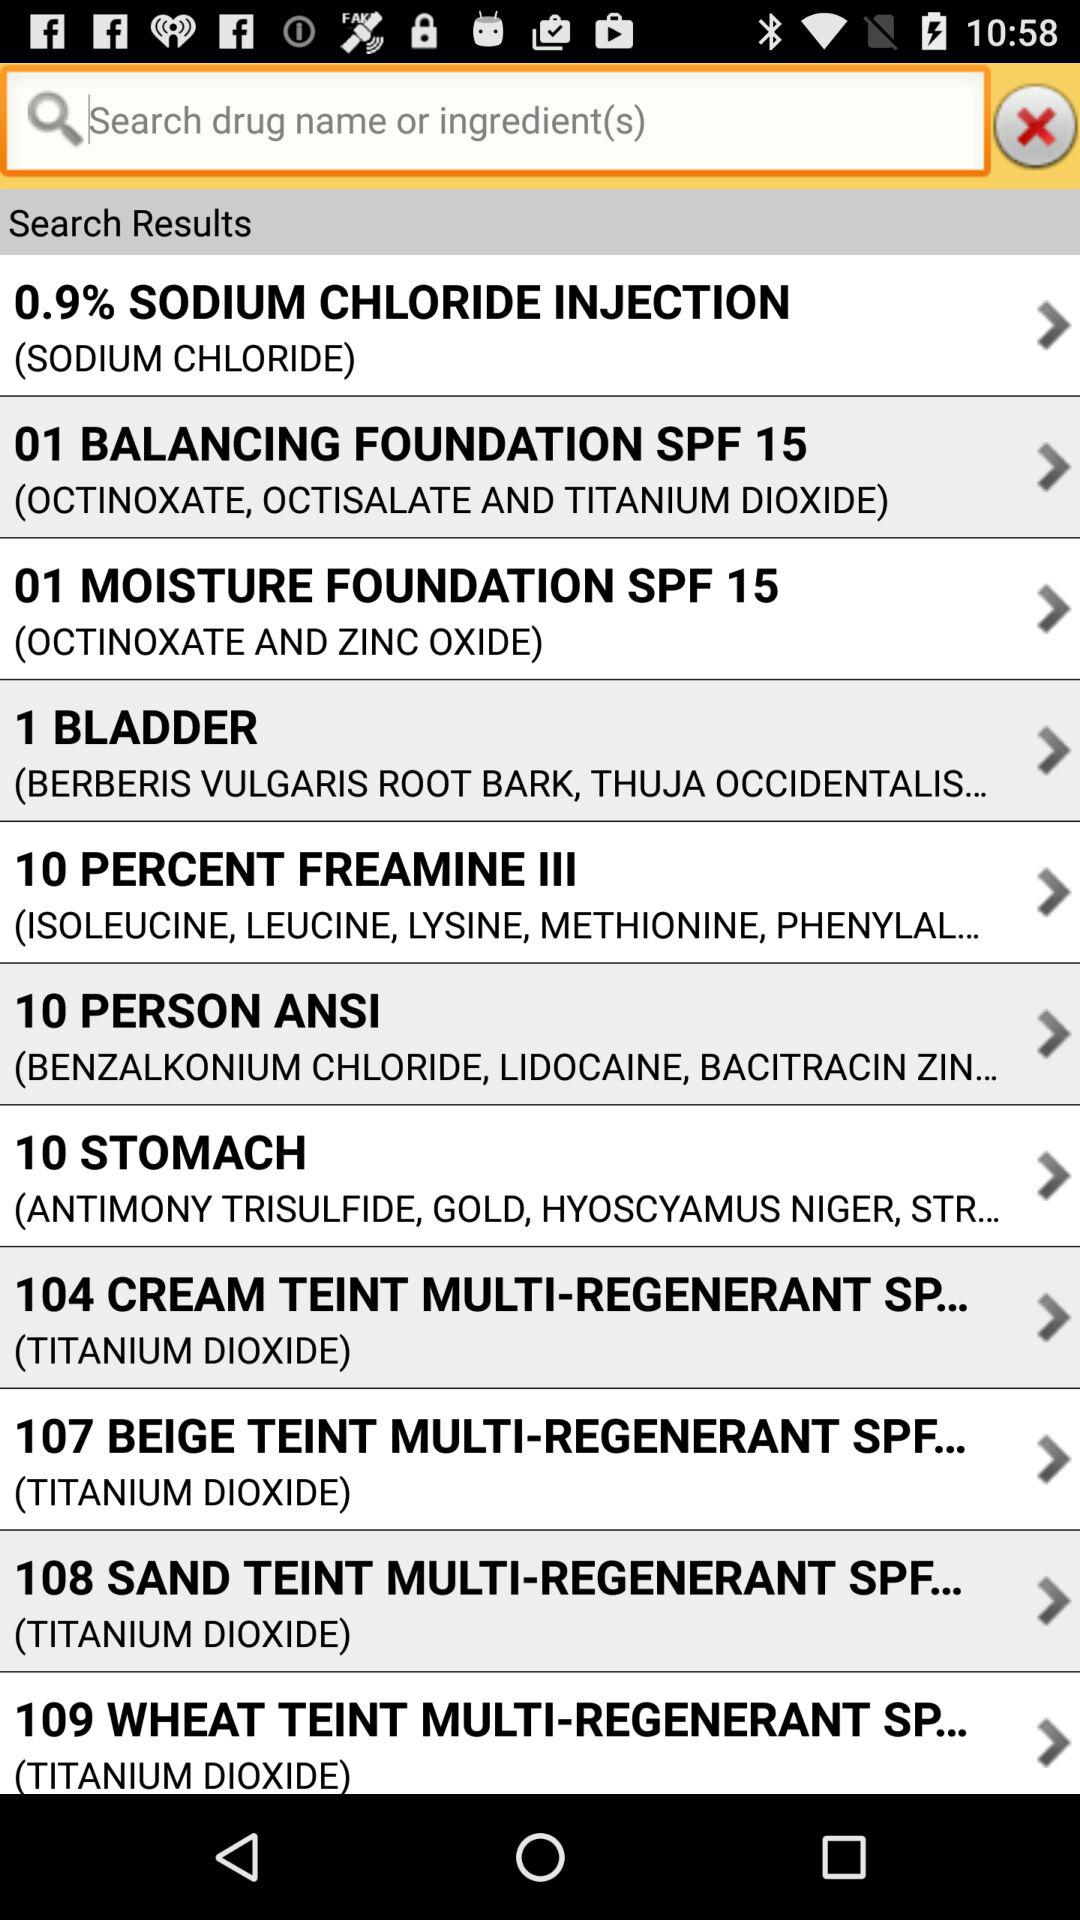What are the ingredients in "1 BLADDER"? The ingredients in "1 BLADDER" are Berberis vulgaris root bark and "THUJA OCCIDENTALIS...". 